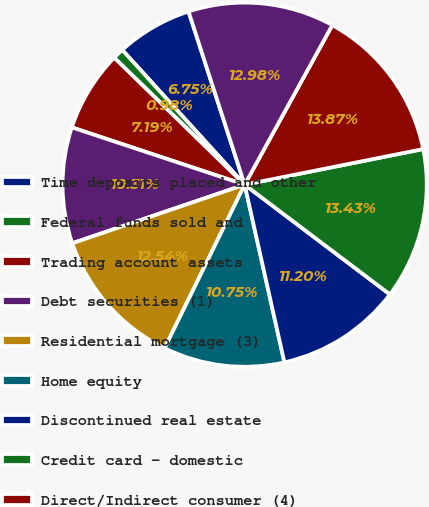Convert chart. <chart><loc_0><loc_0><loc_500><loc_500><pie_chart><fcel>Time deposits placed and other<fcel>Federal funds sold and<fcel>Trading account assets<fcel>Debt securities (1)<fcel>Residential mortgage (3)<fcel>Home equity<fcel>Discontinued real estate<fcel>Credit card - domestic<fcel>Direct/Indirect consumer (4)<fcel>Total consumer<nl><fcel>6.75%<fcel>0.98%<fcel>7.19%<fcel>10.31%<fcel>12.54%<fcel>10.75%<fcel>11.2%<fcel>13.43%<fcel>13.87%<fcel>12.98%<nl></chart> 